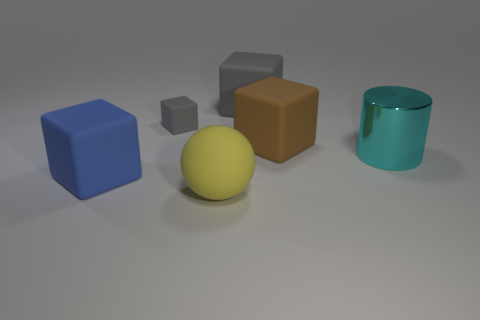What material is the object that is to the right of the large brown block?
Your response must be concise. Metal. Is there any other thing that has the same material as the cyan thing?
Ensure brevity in your answer.  No. Is the number of large rubber objects that are right of the blue object greater than the number of big brown objects?
Ensure brevity in your answer.  Yes. There is a large block that is left of the thing in front of the blue rubber cube; are there any yellow rubber objects that are on the left side of it?
Your answer should be very brief. No. Are there any large brown cubes behind the big cyan metal thing?
Offer a terse response. Yes. What number of big rubber balls have the same color as the small object?
Your answer should be very brief. 0. The blue object that is the same material as the yellow thing is what size?
Your answer should be very brief. Large. How big is the block that is to the right of the gray matte thing to the right of the thing that is in front of the big blue rubber thing?
Provide a succinct answer. Large. How big is the rubber thing in front of the big blue rubber object?
Your response must be concise. Large. How many blue things are either large matte balls or big blocks?
Your answer should be very brief. 1. 